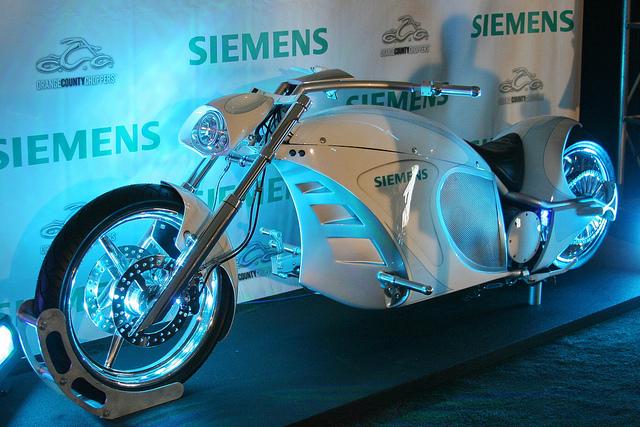What color is the motorcycle?
Answer briefly. White. What brand of motorcycle is this?
Keep it brief. Siemens. Is this a vintage motorcycle?
Answer briefly. No. 